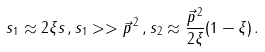Convert formula to latex. <formula><loc_0><loc_0><loc_500><loc_500>s _ { 1 } \approx 2 \xi s \, , s _ { 1 } > > \vec { p } ^ { \, 2 } \, , s _ { 2 } \approx \frac { \vec { p } ^ { \, 2 } } { 2 \xi } ( 1 - \xi ) \, .</formula> 